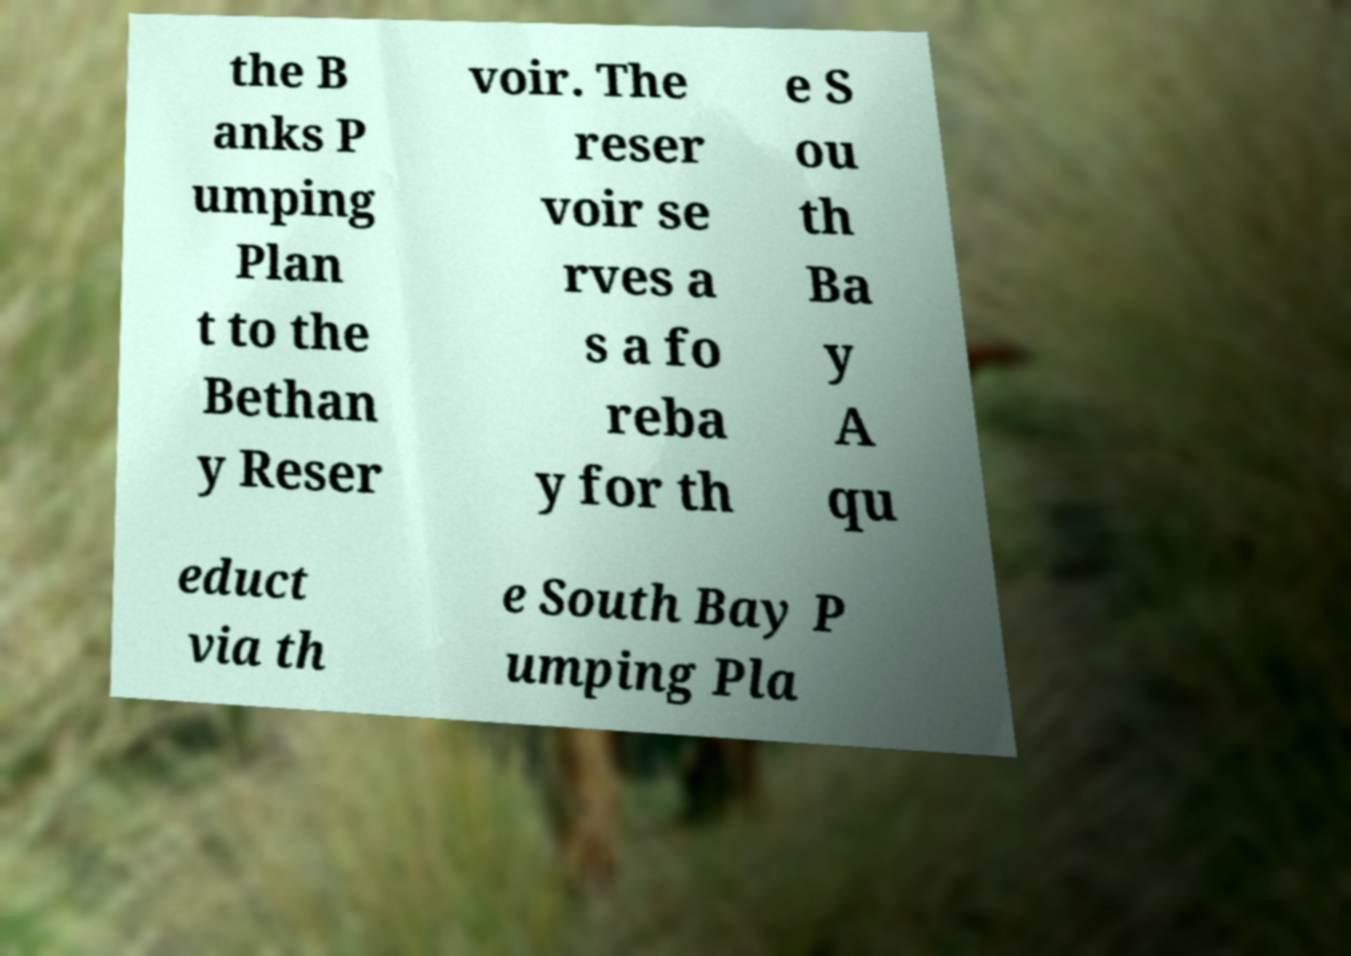I need the written content from this picture converted into text. Can you do that? the B anks P umping Plan t to the Bethan y Reser voir. The reser voir se rves a s a fo reba y for th e S ou th Ba y A qu educt via th e South Bay P umping Pla 